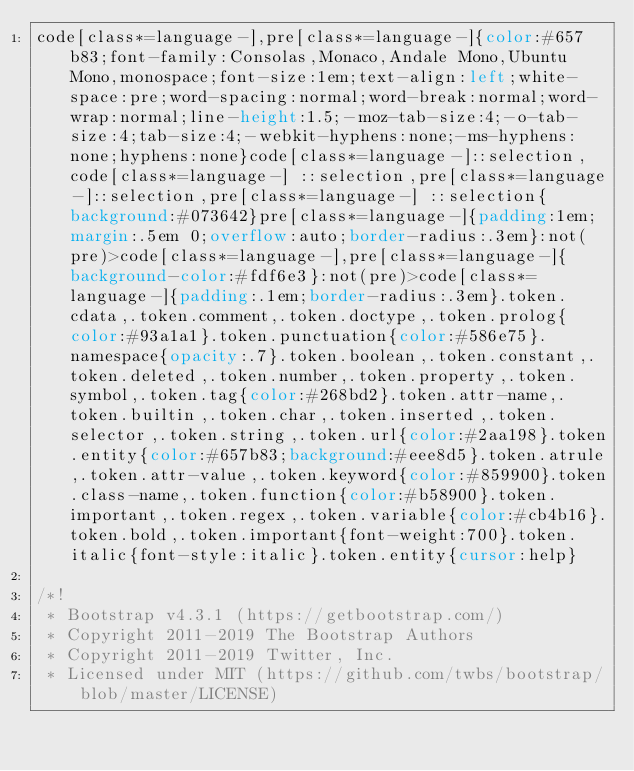Convert code to text. <code><loc_0><loc_0><loc_500><loc_500><_CSS_>code[class*=language-],pre[class*=language-]{color:#657b83;font-family:Consolas,Monaco,Andale Mono,Ubuntu Mono,monospace;font-size:1em;text-align:left;white-space:pre;word-spacing:normal;word-break:normal;word-wrap:normal;line-height:1.5;-moz-tab-size:4;-o-tab-size:4;tab-size:4;-webkit-hyphens:none;-ms-hyphens:none;hyphens:none}code[class*=language-]::selection,code[class*=language-] ::selection,pre[class*=language-]::selection,pre[class*=language-] ::selection{background:#073642}pre[class*=language-]{padding:1em;margin:.5em 0;overflow:auto;border-radius:.3em}:not(pre)>code[class*=language-],pre[class*=language-]{background-color:#fdf6e3}:not(pre)>code[class*=language-]{padding:.1em;border-radius:.3em}.token.cdata,.token.comment,.token.doctype,.token.prolog{color:#93a1a1}.token.punctuation{color:#586e75}.namespace{opacity:.7}.token.boolean,.token.constant,.token.deleted,.token.number,.token.property,.token.symbol,.token.tag{color:#268bd2}.token.attr-name,.token.builtin,.token.char,.token.inserted,.token.selector,.token.string,.token.url{color:#2aa198}.token.entity{color:#657b83;background:#eee8d5}.token.atrule,.token.attr-value,.token.keyword{color:#859900}.token.class-name,.token.function{color:#b58900}.token.important,.token.regex,.token.variable{color:#cb4b16}.token.bold,.token.important{font-weight:700}.token.italic{font-style:italic}.token.entity{cursor:help}

/*!
 * Bootstrap v4.3.1 (https://getbootstrap.com/)
 * Copyright 2011-2019 The Bootstrap Authors
 * Copyright 2011-2019 Twitter, Inc.
 * Licensed under MIT (https://github.com/twbs/bootstrap/blob/master/LICENSE)</code> 